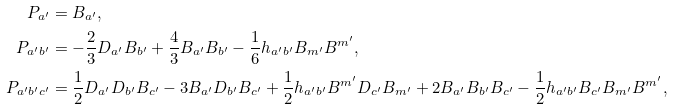Convert formula to latex. <formula><loc_0><loc_0><loc_500><loc_500>P _ { a ^ { \prime } } & = B _ { a ^ { \prime } } , \\ P _ { a ^ { \prime } b ^ { \prime } } & = - \frac { 2 } { 3 } D _ { a ^ { \prime } } B _ { b ^ { \prime } } + \frac { 4 } { 3 } B _ { a ^ { \prime } } B _ { b ^ { \prime } } - \frac { 1 } { 6 } h _ { a ^ { \prime } b ^ { \prime } } B _ { m ^ { \prime } } B ^ { m ^ { \prime } } , \\ P _ { a ^ { \prime } b ^ { \prime } c ^ { \prime } } & = \frac { 1 } { 2 } D _ { a ^ { \prime } } D _ { b ^ { \prime } } B _ { c ^ { \prime } } - 3 B _ { a ^ { \prime } } D _ { b ^ { \prime } } B _ { c ^ { \prime } } + \frac { 1 } { 2 } h _ { a ^ { \prime } b ^ { \prime } } B ^ { m ^ { \prime } } D _ { c ^ { \prime } } B _ { m ^ { \prime } } + 2 B _ { a ^ { \prime } } B _ { b ^ { \prime } } B _ { c ^ { \prime } } - \frac { 1 } { 2 } h _ { a ^ { \prime } b ^ { \prime } } B _ { c ^ { \prime } } B _ { m ^ { \prime } } B ^ { m ^ { \prime } } ,</formula> 